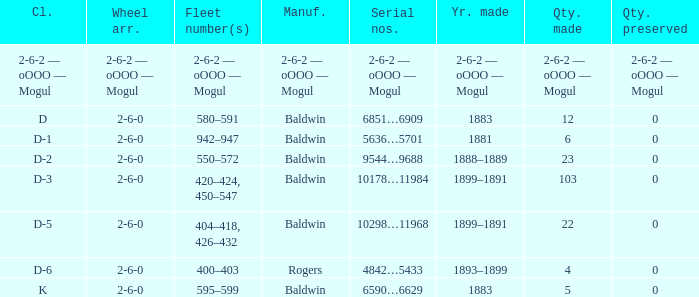What is the wheel arrangement when the year made is 1881? 2-6-0. 